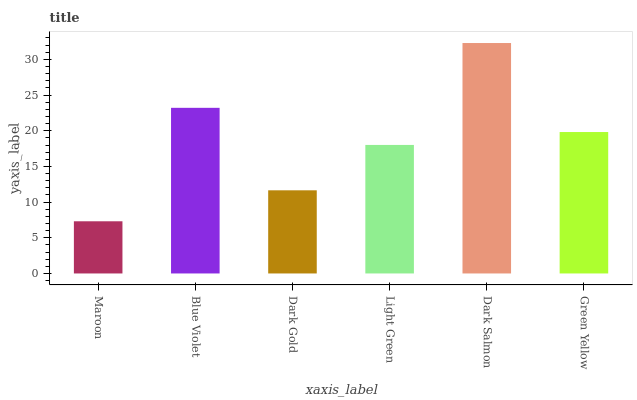Is Maroon the minimum?
Answer yes or no. Yes. Is Dark Salmon the maximum?
Answer yes or no. Yes. Is Blue Violet the minimum?
Answer yes or no. No. Is Blue Violet the maximum?
Answer yes or no. No. Is Blue Violet greater than Maroon?
Answer yes or no. Yes. Is Maroon less than Blue Violet?
Answer yes or no. Yes. Is Maroon greater than Blue Violet?
Answer yes or no. No. Is Blue Violet less than Maroon?
Answer yes or no. No. Is Green Yellow the high median?
Answer yes or no. Yes. Is Light Green the low median?
Answer yes or no. Yes. Is Dark Gold the high median?
Answer yes or no. No. Is Green Yellow the low median?
Answer yes or no. No. 